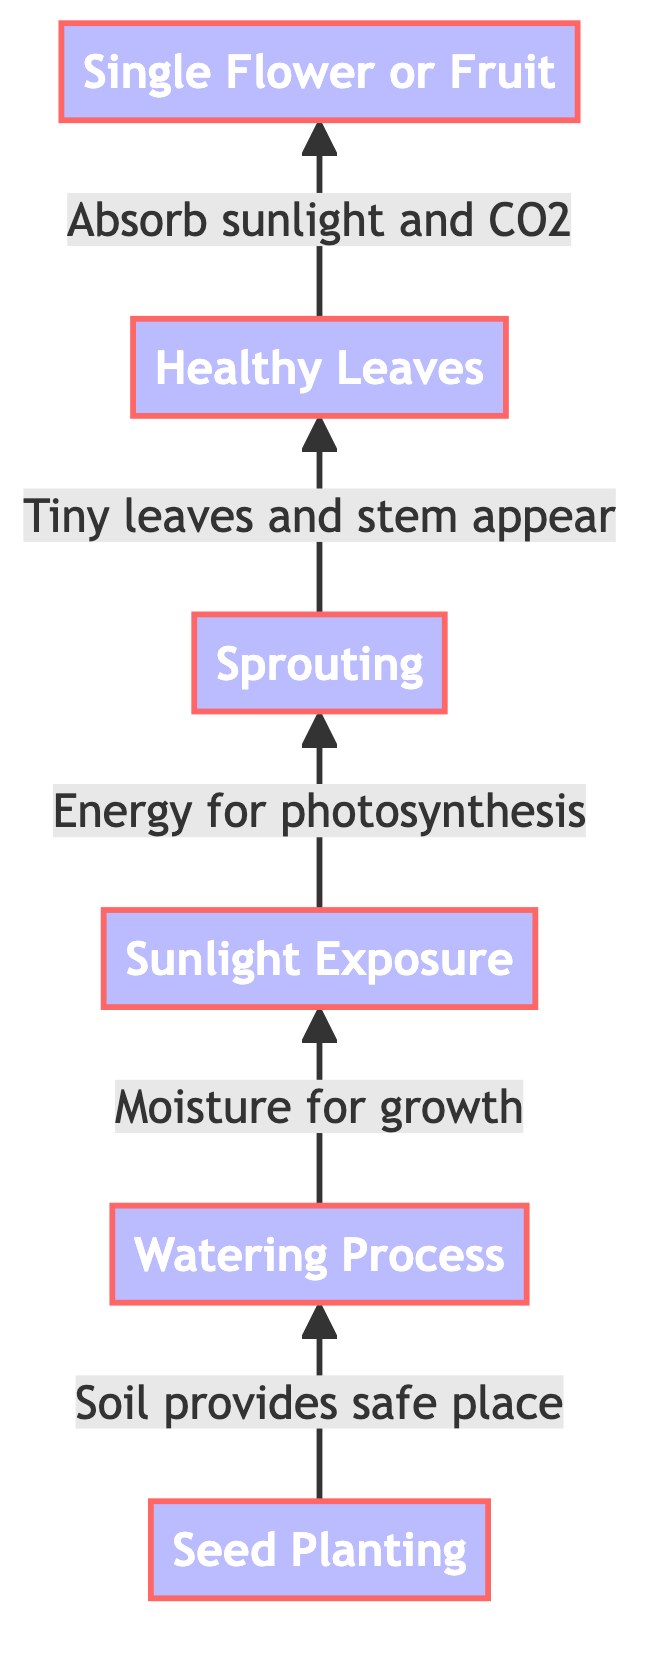What is the first stage in the growth process? The diagram indicates that the first stage in the growth process is "Seed Planting." This is the initial action that begins the entire sequence.
Answer: Seed Planting What comes after the Watering Process? After the Watering Process, the next stage is "Sunlight Exposure." The arrows in the diagram direct from the Watering Process to Sunlight Exposure, following the flow.
Answer: Sunlight Exposure How many stages are shown in the diagram? By counting the nodes in the diagram, there are a total of six stages: Seed Planting, Watering Process, Sunlight Exposure, Sprouting, Healthy Leaves, and Single Flower or Fruit.
Answer: Six What happens before Healthy Leaves? Before Healthy Leaves, the diagram shows "Sprouting" as the prior stage that leads to the development of healthy leaves in the growth process. The flow goes upward from Sprouting to Healthy Leaves.
Answer: Sprouting What does the plant absorb during the Sunlight Exposure stage? During the Sunlight Exposure stage, the description notes that the growing plant absorbs sunlight to create energy for making food via photosynthesis.
Answer: Sunlight Which stage involves the production of fruit or flowers? The last stage in the process, as indicated by the diagram, is "Single Flower or Fruit." This stage represents the completion of the plant's growth cycle.
Answer: Single Flower or Fruit If a seed is not planted, what is the consequence in the growth process? According to the flowchart, without the initial "Seed Planting" stage, the entire growth process cannot begin, indicating that it is the foundational step for all subsequent actions.
Answer: No growth What is the relationship between Healthy Leaves and Sunlight Exposure? The relationship here is that healthy leaves are developed after the Sunlight Exposure stage, which is essential for absorbing the sunlight necessary for food production and growth.
Answer: Development after exposure What type of diagram is this, and what is its direction? This is a programming flowchart, and the direction is bottom to up, showing the process from the initial planting of a seed at the bottom to the final flowering stage at the top.
Answer: Programming flowchart, bottom to up 